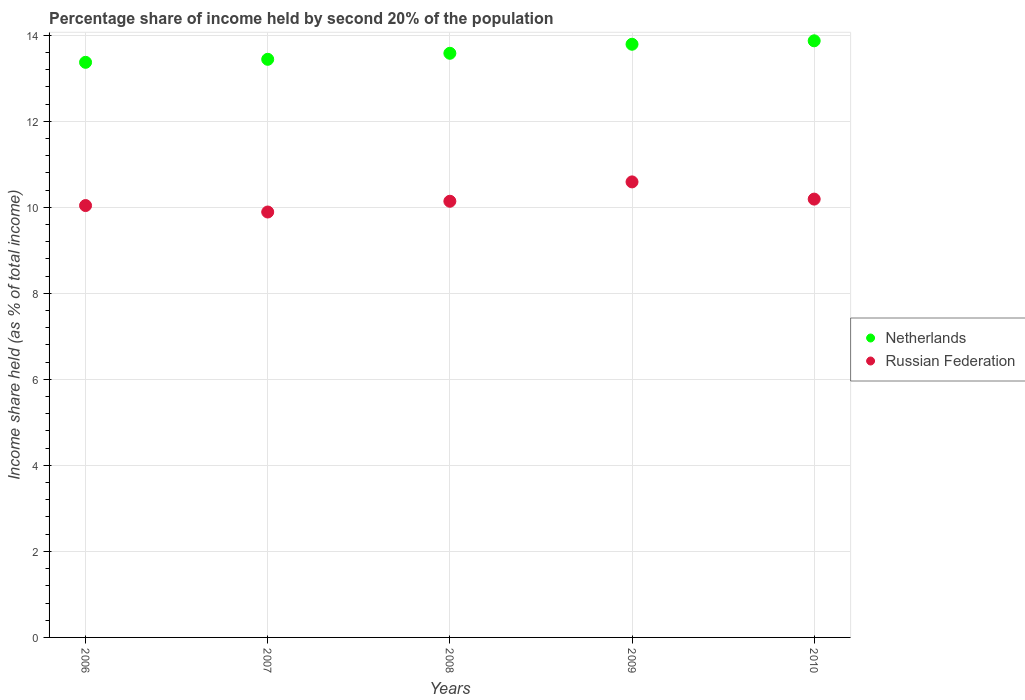How many different coloured dotlines are there?
Provide a short and direct response. 2. What is the share of income held by second 20% of the population in Russian Federation in 2010?
Your answer should be compact. 10.19. Across all years, what is the maximum share of income held by second 20% of the population in Russian Federation?
Make the answer very short. 10.59. Across all years, what is the minimum share of income held by second 20% of the population in Netherlands?
Make the answer very short. 13.37. In which year was the share of income held by second 20% of the population in Russian Federation maximum?
Your answer should be compact. 2009. What is the total share of income held by second 20% of the population in Russian Federation in the graph?
Offer a terse response. 50.85. What is the difference between the share of income held by second 20% of the population in Russian Federation in 2008 and that in 2009?
Your answer should be very brief. -0.45. What is the difference between the share of income held by second 20% of the population in Netherlands in 2010 and the share of income held by second 20% of the population in Russian Federation in 2007?
Provide a short and direct response. 3.98. What is the average share of income held by second 20% of the population in Netherlands per year?
Provide a short and direct response. 13.61. In the year 2008, what is the difference between the share of income held by second 20% of the population in Netherlands and share of income held by second 20% of the population in Russian Federation?
Your answer should be compact. 3.44. In how many years, is the share of income held by second 20% of the population in Russian Federation greater than 11.2 %?
Provide a succinct answer. 0. What is the ratio of the share of income held by second 20% of the population in Russian Federation in 2007 to that in 2010?
Offer a very short reply. 0.97. What is the difference between the highest and the second highest share of income held by second 20% of the population in Netherlands?
Provide a short and direct response. 0.08. What is the difference between the highest and the lowest share of income held by second 20% of the population in Russian Federation?
Your response must be concise. 0.7. Is the sum of the share of income held by second 20% of the population in Russian Federation in 2006 and 2010 greater than the maximum share of income held by second 20% of the population in Netherlands across all years?
Offer a very short reply. Yes. Does the share of income held by second 20% of the population in Netherlands monotonically increase over the years?
Keep it short and to the point. Yes. How many dotlines are there?
Your answer should be compact. 2. How many years are there in the graph?
Offer a terse response. 5. Where does the legend appear in the graph?
Your answer should be very brief. Center right. What is the title of the graph?
Your response must be concise. Percentage share of income held by second 20% of the population. Does "Malta" appear as one of the legend labels in the graph?
Ensure brevity in your answer.  No. What is the label or title of the Y-axis?
Provide a short and direct response. Income share held (as % of total income). What is the Income share held (as % of total income) of Netherlands in 2006?
Provide a short and direct response. 13.37. What is the Income share held (as % of total income) in Russian Federation in 2006?
Offer a terse response. 10.04. What is the Income share held (as % of total income) in Netherlands in 2007?
Offer a very short reply. 13.44. What is the Income share held (as % of total income) of Russian Federation in 2007?
Offer a terse response. 9.89. What is the Income share held (as % of total income) in Netherlands in 2008?
Make the answer very short. 13.58. What is the Income share held (as % of total income) of Russian Federation in 2008?
Offer a very short reply. 10.14. What is the Income share held (as % of total income) in Netherlands in 2009?
Give a very brief answer. 13.79. What is the Income share held (as % of total income) in Russian Federation in 2009?
Your response must be concise. 10.59. What is the Income share held (as % of total income) in Netherlands in 2010?
Give a very brief answer. 13.87. What is the Income share held (as % of total income) of Russian Federation in 2010?
Give a very brief answer. 10.19. Across all years, what is the maximum Income share held (as % of total income) in Netherlands?
Provide a short and direct response. 13.87. Across all years, what is the maximum Income share held (as % of total income) in Russian Federation?
Offer a terse response. 10.59. Across all years, what is the minimum Income share held (as % of total income) of Netherlands?
Provide a succinct answer. 13.37. Across all years, what is the minimum Income share held (as % of total income) in Russian Federation?
Keep it short and to the point. 9.89. What is the total Income share held (as % of total income) in Netherlands in the graph?
Provide a succinct answer. 68.05. What is the total Income share held (as % of total income) in Russian Federation in the graph?
Offer a terse response. 50.85. What is the difference between the Income share held (as % of total income) in Netherlands in 2006 and that in 2007?
Ensure brevity in your answer.  -0.07. What is the difference between the Income share held (as % of total income) in Russian Federation in 2006 and that in 2007?
Make the answer very short. 0.15. What is the difference between the Income share held (as % of total income) in Netherlands in 2006 and that in 2008?
Ensure brevity in your answer.  -0.21. What is the difference between the Income share held (as % of total income) in Netherlands in 2006 and that in 2009?
Your response must be concise. -0.42. What is the difference between the Income share held (as % of total income) in Russian Federation in 2006 and that in 2009?
Your response must be concise. -0.55. What is the difference between the Income share held (as % of total income) of Russian Federation in 2006 and that in 2010?
Offer a terse response. -0.15. What is the difference between the Income share held (as % of total income) of Netherlands in 2007 and that in 2008?
Your answer should be compact. -0.14. What is the difference between the Income share held (as % of total income) of Netherlands in 2007 and that in 2009?
Your answer should be very brief. -0.35. What is the difference between the Income share held (as % of total income) of Netherlands in 2007 and that in 2010?
Provide a succinct answer. -0.43. What is the difference between the Income share held (as % of total income) of Netherlands in 2008 and that in 2009?
Keep it short and to the point. -0.21. What is the difference between the Income share held (as % of total income) of Russian Federation in 2008 and that in 2009?
Your response must be concise. -0.45. What is the difference between the Income share held (as % of total income) in Netherlands in 2008 and that in 2010?
Offer a terse response. -0.29. What is the difference between the Income share held (as % of total income) of Netherlands in 2009 and that in 2010?
Your answer should be compact. -0.08. What is the difference between the Income share held (as % of total income) of Netherlands in 2006 and the Income share held (as % of total income) of Russian Federation in 2007?
Your answer should be compact. 3.48. What is the difference between the Income share held (as % of total income) in Netherlands in 2006 and the Income share held (as % of total income) in Russian Federation in 2008?
Your answer should be compact. 3.23. What is the difference between the Income share held (as % of total income) in Netherlands in 2006 and the Income share held (as % of total income) in Russian Federation in 2009?
Keep it short and to the point. 2.78. What is the difference between the Income share held (as % of total income) of Netherlands in 2006 and the Income share held (as % of total income) of Russian Federation in 2010?
Provide a short and direct response. 3.18. What is the difference between the Income share held (as % of total income) of Netherlands in 2007 and the Income share held (as % of total income) of Russian Federation in 2008?
Make the answer very short. 3.3. What is the difference between the Income share held (as % of total income) in Netherlands in 2007 and the Income share held (as % of total income) in Russian Federation in 2009?
Make the answer very short. 2.85. What is the difference between the Income share held (as % of total income) in Netherlands in 2007 and the Income share held (as % of total income) in Russian Federation in 2010?
Your answer should be compact. 3.25. What is the difference between the Income share held (as % of total income) in Netherlands in 2008 and the Income share held (as % of total income) in Russian Federation in 2009?
Your answer should be compact. 2.99. What is the difference between the Income share held (as % of total income) in Netherlands in 2008 and the Income share held (as % of total income) in Russian Federation in 2010?
Keep it short and to the point. 3.39. What is the average Income share held (as % of total income) of Netherlands per year?
Provide a succinct answer. 13.61. What is the average Income share held (as % of total income) in Russian Federation per year?
Offer a very short reply. 10.17. In the year 2006, what is the difference between the Income share held (as % of total income) in Netherlands and Income share held (as % of total income) in Russian Federation?
Your answer should be very brief. 3.33. In the year 2007, what is the difference between the Income share held (as % of total income) of Netherlands and Income share held (as % of total income) of Russian Federation?
Provide a succinct answer. 3.55. In the year 2008, what is the difference between the Income share held (as % of total income) of Netherlands and Income share held (as % of total income) of Russian Federation?
Ensure brevity in your answer.  3.44. In the year 2009, what is the difference between the Income share held (as % of total income) in Netherlands and Income share held (as % of total income) in Russian Federation?
Offer a terse response. 3.2. In the year 2010, what is the difference between the Income share held (as % of total income) of Netherlands and Income share held (as % of total income) of Russian Federation?
Ensure brevity in your answer.  3.68. What is the ratio of the Income share held (as % of total income) of Netherlands in 2006 to that in 2007?
Your answer should be compact. 0.99. What is the ratio of the Income share held (as % of total income) in Russian Federation in 2006 to that in 2007?
Provide a short and direct response. 1.02. What is the ratio of the Income share held (as % of total income) in Netherlands in 2006 to that in 2008?
Your answer should be compact. 0.98. What is the ratio of the Income share held (as % of total income) in Netherlands in 2006 to that in 2009?
Offer a terse response. 0.97. What is the ratio of the Income share held (as % of total income) in Russian Federation in 2006 to that in 2009?
Provide a short and direct response. 0.95. What is the ratio of the Income share held (as % of total income) of Netherlands in 2006 to that in 2010?
Your answer should be compact. 0.96. What is the ratio of the Income share held (as % of total income) in Netherlands in 2007 to that in 2008?
Provide a succinct answer. 0.99. What is the ratio of the Income share held (as % of total income) in Russian Federation in 2007 to that in 2008?
Provide a short and direct response. 0.98. What is the ratio of the Income share held (as % of total income) of Netherlands in 2007 to that in 2009?
Your answer should be compact. 0.97. What is the ratio of the Income share held (as % of total income) in Russian Federation in 2007 to that in 2009?
Your answer should be compact. 0.93. What is the ratio of the Income share held (as % of total income) in Netherlands in 2007 to that in 2010?
Ensure brevity in your answer.  0.97. What is the ratio of the Income share held (as % of total income) in Russian Federation in 2007 to that in 2010?
Offer a terse response. 0.97. What is the ratio of the Income share held (as % of total income) in Russian Federation in 2008 to that in 2009?
Ensure brevity in your answer.  0.96. What is the ratio of the Income share held (as % of total income) of Netherlands in 2008 to that in 2010?
Give a very brief answer. 0.98. What is the ratio of the Income share held (as % of total income) in Netherlands in 2009 to that in 2010?
Keep it short and to the point. 0.99. What is the ratio of the Income share held (as % of total income) in Russian Federation in 2009 to that in 2010?
Provide a short and direct response. 1.04. What is the difference between the highest and the second highest Income share held (as % of total income) in Netherlands?
Offer a very short reply. 0.08. 